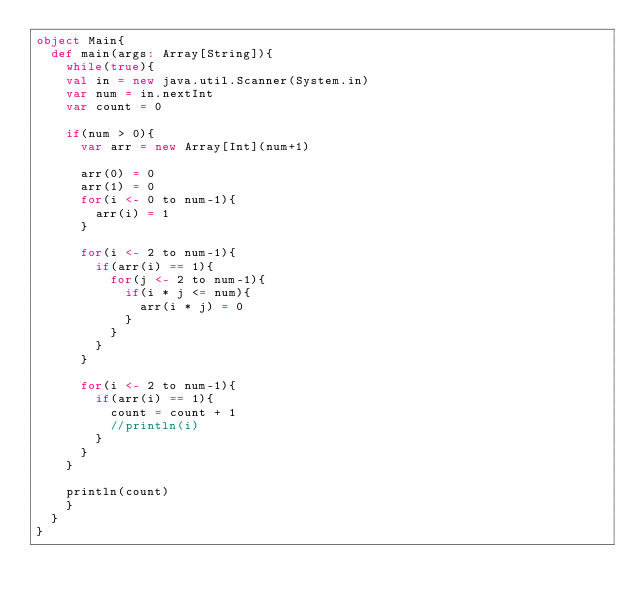<code> <loc_0><loc_0><loc_500><loc_500><_Scala_>object Main{
  def main(args: Array[String]){
    while(true){
    val in = new java.util.Scanner(System.in)
    var num = in.nextInt
    var count = 0

    if(num > 0){
      var arr = new Array[Int](num+1)

      arr(0) = 0
      arr(1) = 0
      for(i <- 0 to num-1){
        arr(i) = 1
      }

      for(i <- 2 to num-1){
        if(arr(i) == 1){
          for(j <- 2 to num-1){
            if(i * j <= num){
              arr(i * j) = 0
            }
          }
        }
      }

      for(i <- 2 to num-1){
        if(arr(i) == 1){
          count = count + 1
          //println(i)
        }
      }
    }

    println(count)
    }
  }
}</code> 